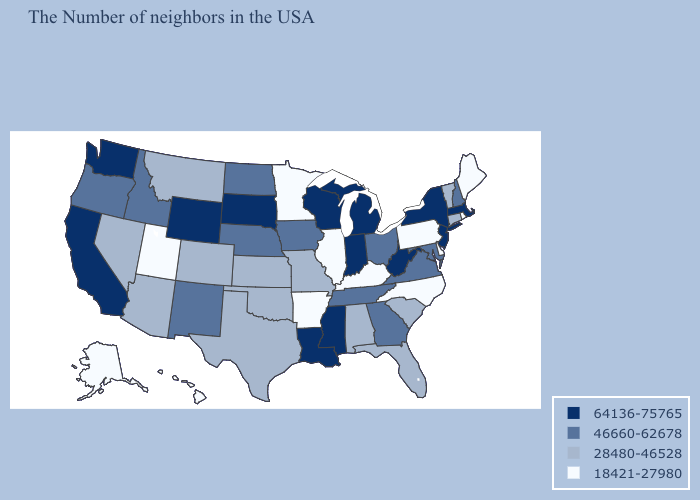Which states hav the highest value in the MidWest?
Short answer required. Michigan, Indiana, Wisconsin, South Dakota. Among the states that border Virginia , does Tennessee have the lowest value?
Concise answer only. No. Name the states that have a value in the range 46660-62678?
Be succinct. New Hampshire, Maryland, Virginia, Ohio, Georgia, Tennessee, Iowa, Nebraska, North Dakota, New Mexico, Idaho, Oregon. Name the states that have a value in the range 18421-27980?
Give a very brief answer. Maine, Rhode Island, Delaware, Pennsylvania, North Carolina, Kentucky, Illinois, Arkansas, Minnesota, Utah, Alaska, Hawaii. What is the value of South Dakota?
Answer briefly. 64136-75765. What is the value of Maine?
Quick response, please. 18421-27980. What is the value of Connecticut?
Concise answer only. 28480-46528. What is the value of Indiana?
Be succinct. 64136-75765. What is the highest value in the Northeast ?
Be succinct. 64136-75765. Which states have the lowest value in the USA?
Short answer required. Maine, Rhode Island, Delaware, Pennsylvania, North Carolina, Kentucky, Illinois, Arkansas, Minnesota, Utah, Alaska, Hawaii. How many symbols are there in the legend?
Be succinct. 4. What is the lowest value in states that border Washington?
Quick response, please. 46660-62678. Name the states that have a value in the range 28480-46528?
Answer briefly. Vermont, Connecticut, South Carolina, Florida, Alabama, Missouri, Kansas, Oklahoma, Texas, Colorado, Montana, Arizona, Nevada. What is the value of New Jersey?
Answer briefly. 64136-75765. What is the value of North Dakota?
Write a very short answer. 46660-62678. 